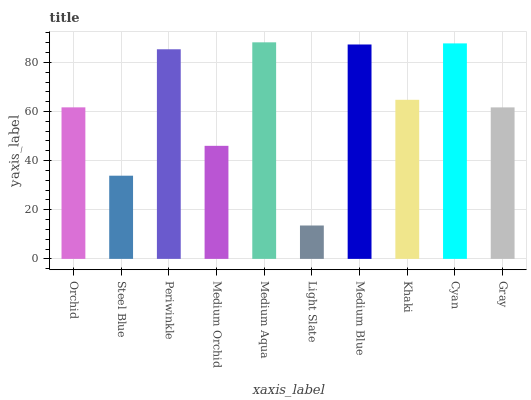Is Light Slate the minimum?
Answer yes or no. Yes. Is Medium Aqua the maximum?
Answer yes or no. Yes. Is Steel Blue the minimum?
Answer yes or no. No. Is Steel Blue the maximum?
Answer yes or no. No. Is Orchid greater than Steel Blue?
Answer yes or no. Yes. Is Steel Blue less than Orchid?
Answer yes or no. Yes. Is Steel Blue greater than Orchid?
Answer yes or no. No. Is Orchid less than Steel Blue?
Answer yes or no. No. Is Khaki the high median?
Answer yes or no. Yes. Is Orchid the low median?
Answer yes or no. Yes. Is Periwinkle the high median?
Answer yes or no. No. Is Gray the low median?
Answer yes or no. No. 